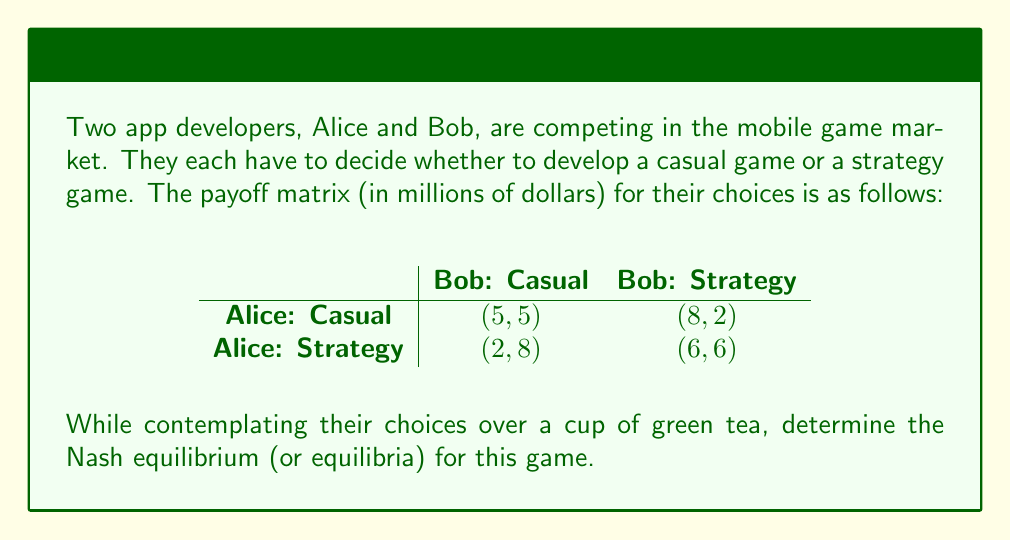Provide a solution to this math problem. To find the Nash equilibrium, we need to analyze each player's best response to the other player's strategy:

1. Alice's perspective:
   - If Bob chooses Casual:
     - Alice choosing Casual yields $5 million
     - Alice choosing Strategy yields $2 million
     - Best response: Casual
   - If Bob chooses Strategy:
     - Alice choosing Casual yields $8 million
     - Alice choosing Strategy yields $6 million
     - Best response: Casual

2. Bob's perspective:
   - If Alice chooses Casual:
     - Bob choosing Casual yields $5 million
     - Bob choosing Strategy yields $2 million
     - Best response: Casual
   - If Alice chooses Strategy:
     - Bob choosing Casual yields $8 million
     - Bob choosing Strategy yields $6 million
     - Best response: Casual

3. Identifying Nash equilibrium:
   A Nash equilibrium occurs when both players are playing their best response to the other player's strategy. From our analysis, we can see that:
   
   - When Alice chooses Casual, Bob's best response is Casual
   - When Bob chooses Casual, Alice's best response is Casual

Therefore, the Nash equilibrium for this game is (Casual, Casual), resulting in a payoff of (5, 5) million dollars for Alice and Bob, respectively.

Note: This is a unique Nash equilibrium in pure strategies for this game.
Answer: The Nash equilibrium is (Casual, Casual) with payoffs of (5, 5) million dollars for Alice and Bob, respectively. 